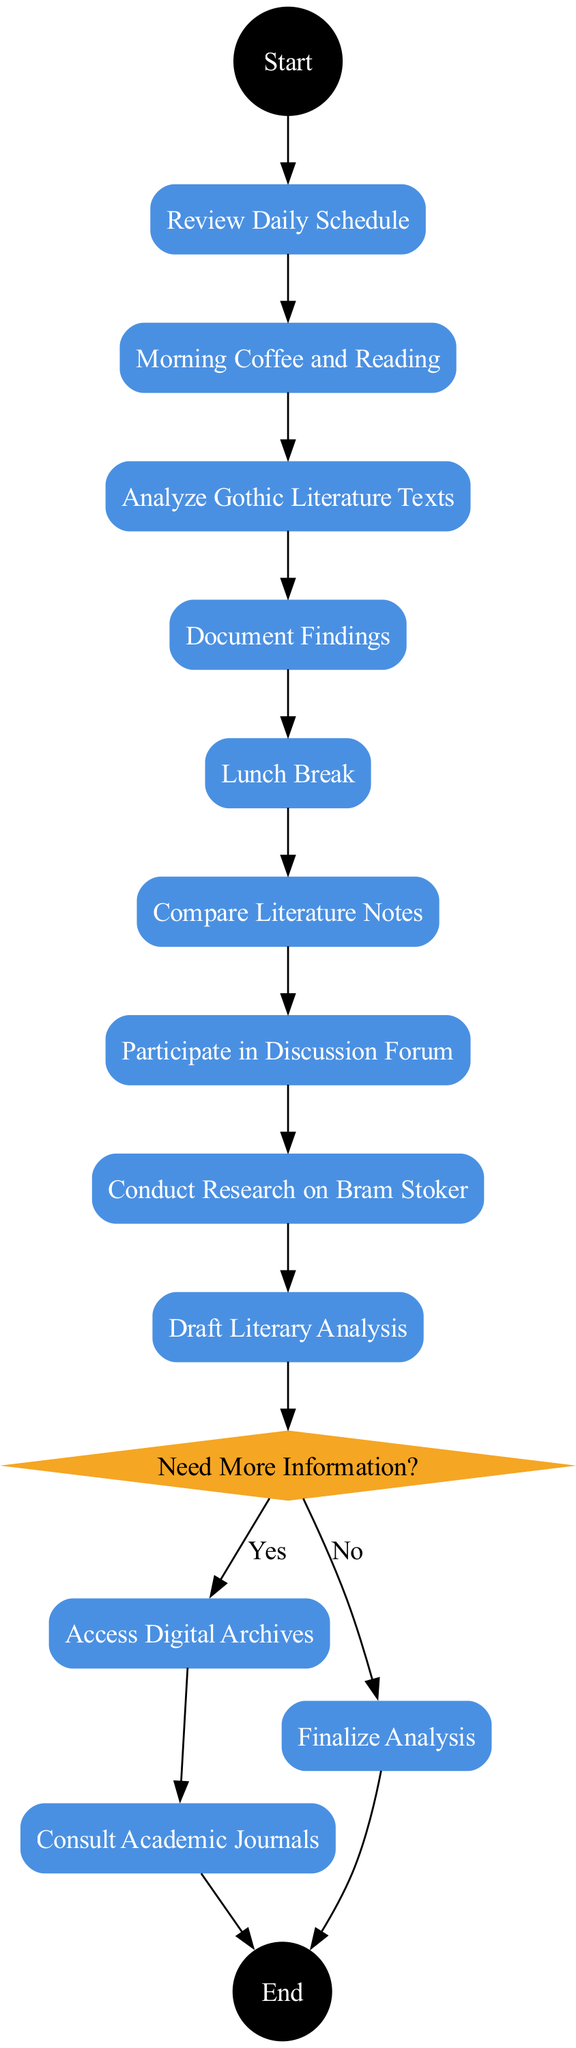What is the first activity in the daily routine? The first activity listed after the start event is "Review Daily Schedule," which follows directly from the start node.
Answer: Review Daily Schedule How many tasks are there in the daily routine? Counting all activities labeled as tasks in the diagram, there are eight tasks, including "Review Daily Schedule" through to "Draft Literary Analysis."
Answer: Eight What happens after "Document Findings"? After "Document Findings," the decision node "Need More Information?" is reached, which determines the next activities based on whether the answer is yes or no.
Answer: Need More Information? What is the last activity in the "Yes" branch of the decision? In the "Yes" branch, after "Access Digital Archives" and "Consult Academic Journals," the flow finally leads to the end event, making "Access Digital Archives" the last specific task in that branch.
Answer: Access Digital Archives Which activity leads to the end event if the decision is "No"? If the answer to the decision "Need More Information?" is "No," the next activity is "Finalize Analysis," which directly leads to the end event.
Answer: Finalize Analysis What is the decision condition after the task "Document Findings"? The decision condition after "Document Findings" is "Need More Information?" determining how to proceed based on the scholar's requirement for further data.
Answer: Need More Information? How many total edges are in the diagram? By counting the edges connecting nodes, there are ten edges total: from the start node through all activities to the decision and branching points, ending with edges to the end event.
Answer: Ten What is the shape of the nodes representing tasks? The nodes representing tasks are shaped like rectangles and filled with a rounded style, defined in the diagram attributes for tasks.
Answer: Rectangle What visual representation is used for the start and end events? Both the start and end events are visually represented as circles filled in black with white text for clarity and emphasis in the diagram.
Answer: Circle 